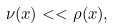Convert formula to latex. <formula><loc_0><loc_0><loc_500><loc_500>\nu ( x ) < < \rho ( x ) ,</formula> 